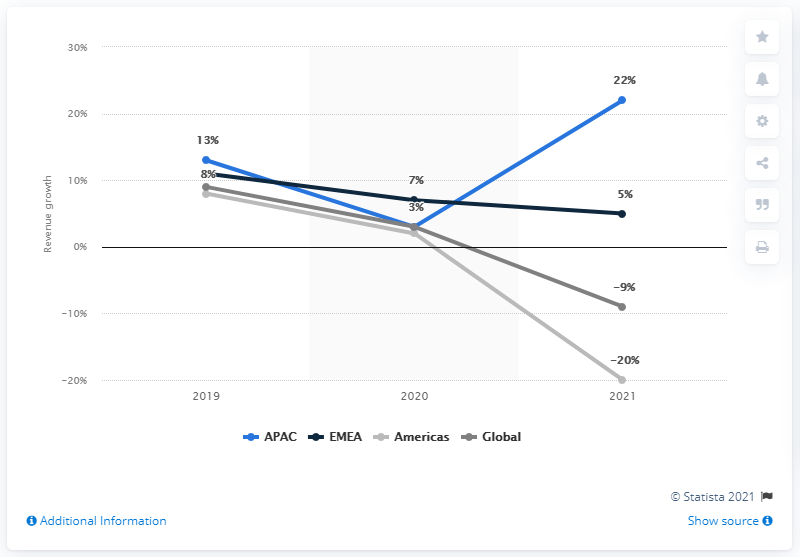Draw attention to some important aspects in this diagram. VF Corporation's The North Face brand reported a significant increase in revenues in the APAC region in fiscal year 2021. 